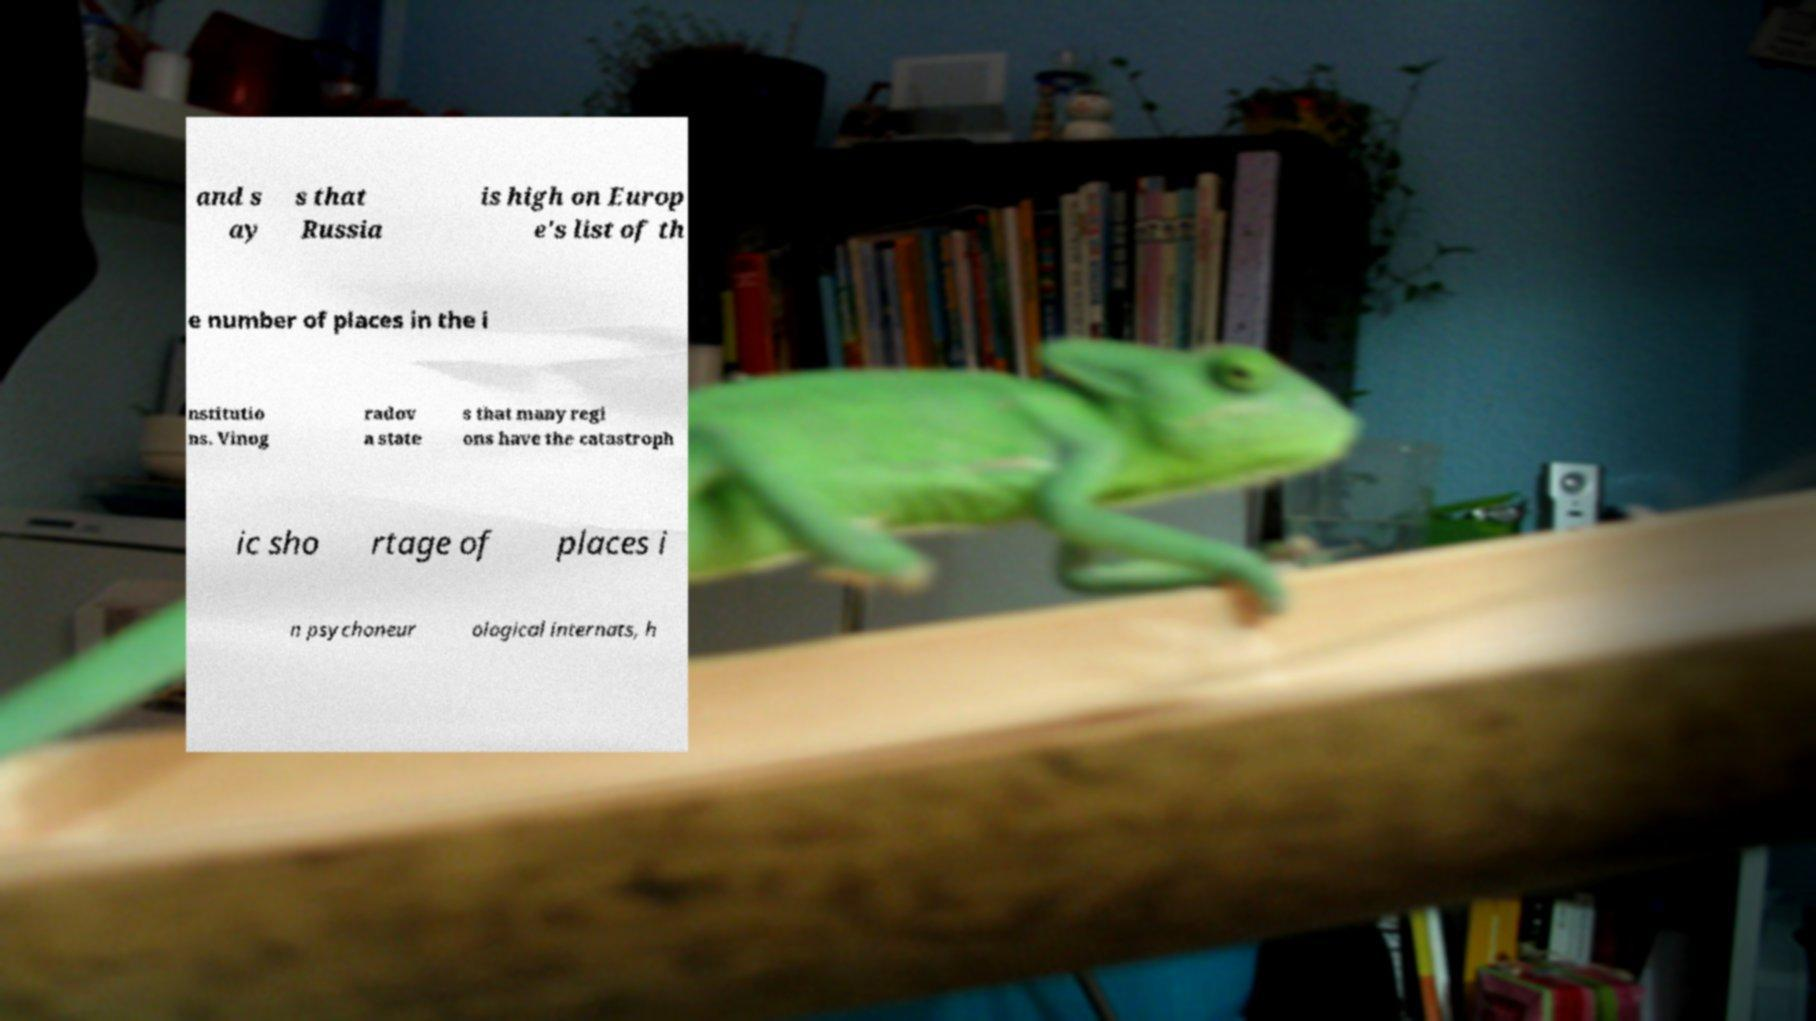Please read and relay the text visible in this image. What does it say? and s ay s that Russia is high on Europ e's list of th e number of places in the i nstitutio ns. Vinog radov a state s that many regi ons have the catastroph ic sho rtage of places i n psychoneur ological internats, h 